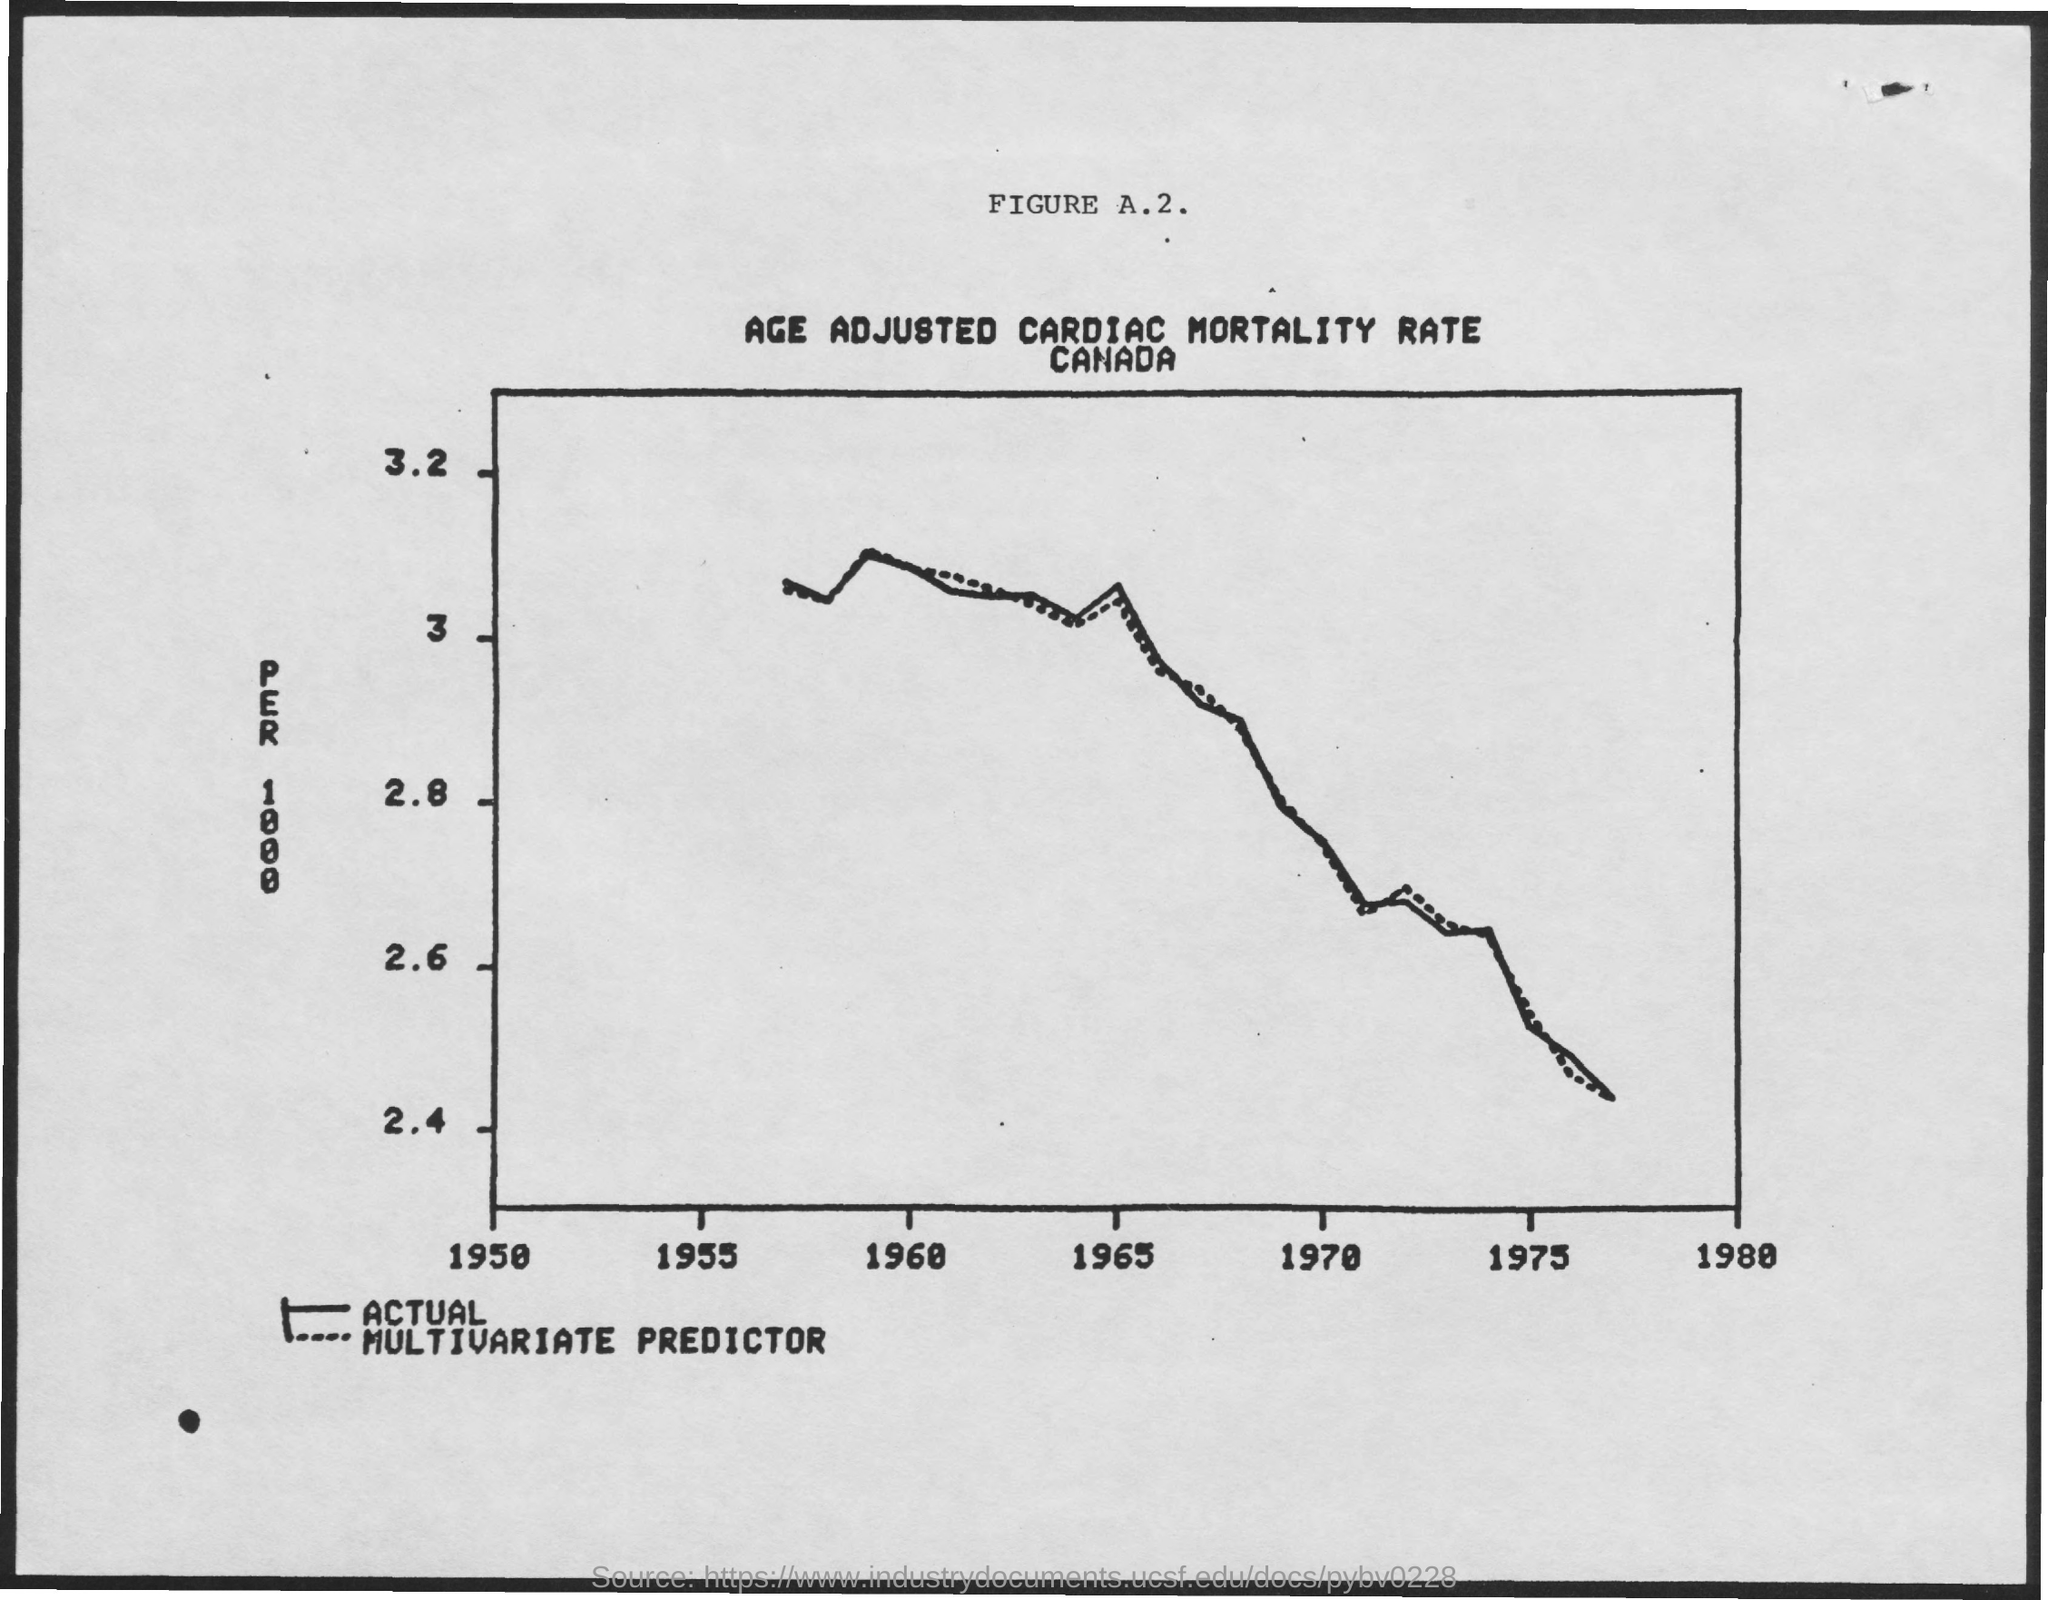What is the name of the country mentioned in the document?
Provide a succinct answer. Canada. 